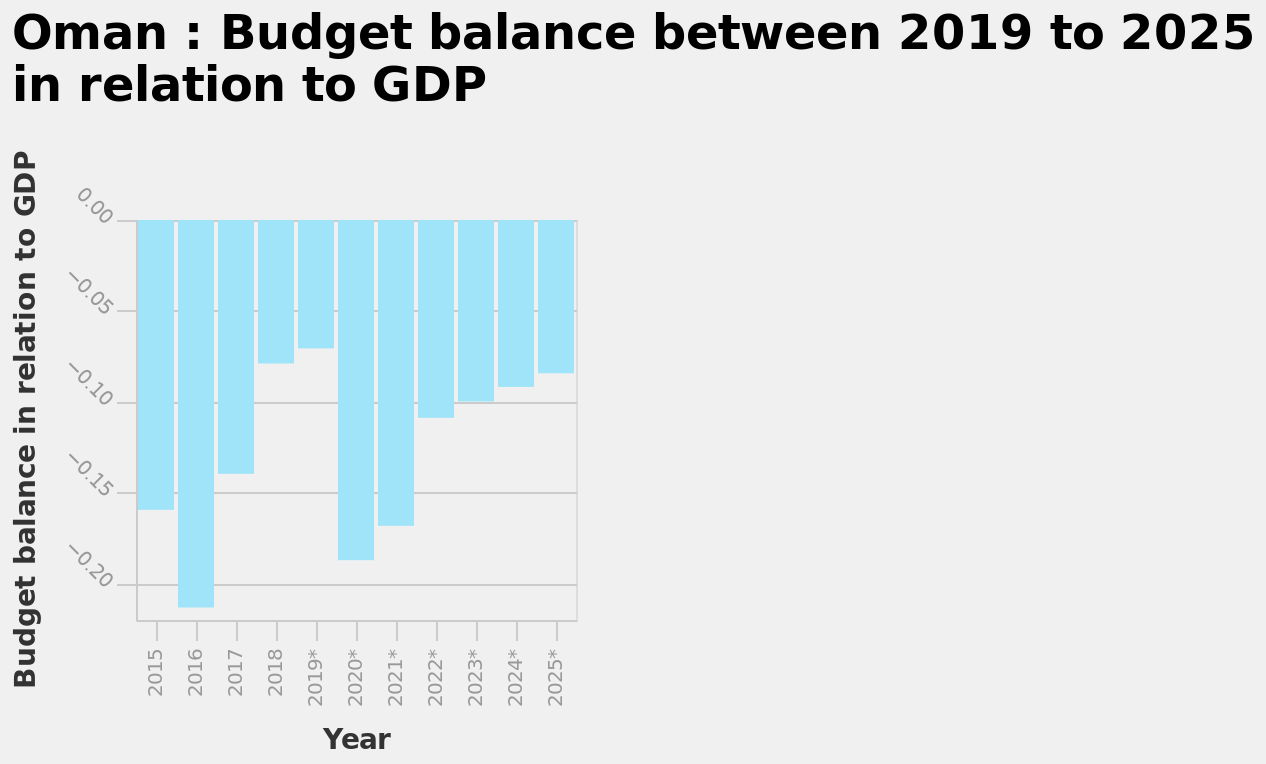<image>
What is the largest balance observed in Oman's budget? The largest balance observed in Oman's budget is approximately -0.23. please enumerates aspects of the construction of the chart This is a bar plot named Oman : Budget balance between 2019 to 2025 in relation to GDP. There is a categorical scale with −0.20 on one end and 0.00 at the other on the y-axis, labeled Budget balance in relation to GDP. Along the x-axis, Year is defined with a categorical scale from 2015 to 2025*. 